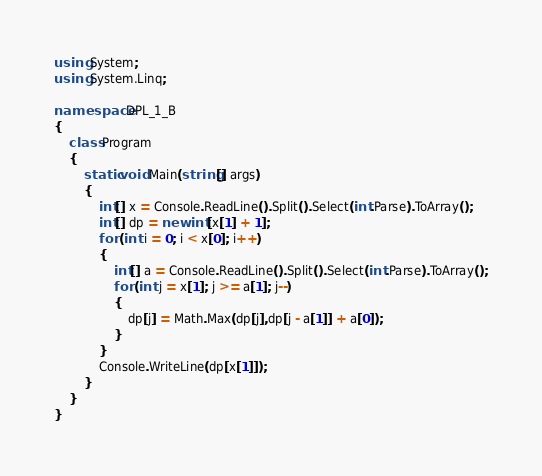<code> <loc_0><loc_0><loc_500><loc_500><_C#_>using System;
using System.Linq;

namespace DPL_1_B
{
    class Program
    {
        static void Main(string[] args)
        {
            int[] x = Console.ReadLine().Split().Select(int.Parse).ToArray();
            int[] dp = new int[x[1] + 1];
            for (int i = 0; i < x[0]; i++)
            {
                int[] a = Console.ReadLine().Split().Select(int.Parse).ToArray();
                for (int j = x[1]; j >= a[1]; j--)
                {
                    dp[j] = Math.Max(dp[j],dp[j - a[1]] + a[0]);
                }
            }
            Console.WriteLine(dp[x[1]]);
        }
    }
}
</code> 